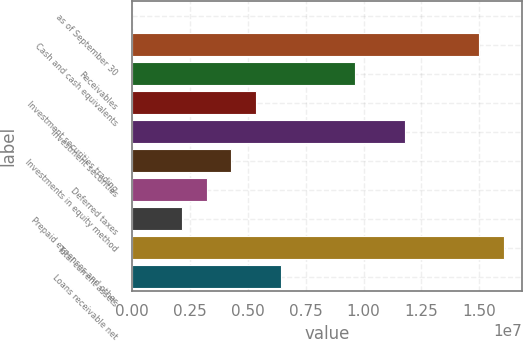Convert chart to OTSL. <chart><loc_0><loc_0><loc_500><loc_500><bar_chart><fcel>as of September 30<fcel>Cash and cash equivalents<fcel>Receivables<fcel>Investment securities trading<fcel>Investment securities<fcel>Investments in equity method<fcel>Deferred taxes<fcel>Prepaid expenses and other<fcel>Total current assets<fcel>Loans receivable net<nl><fcel>2010<fcel>1.49905e+07<fcel>9.63748e+06<fcel>5.35505e+06<fcel>1.17787e+07<fcel>4.28444e+06<fcel>3.21383e+06<fcel>2.14323e+06<fcel>1.60611e+07<fcel>6.42566e+06<nl></chart> 